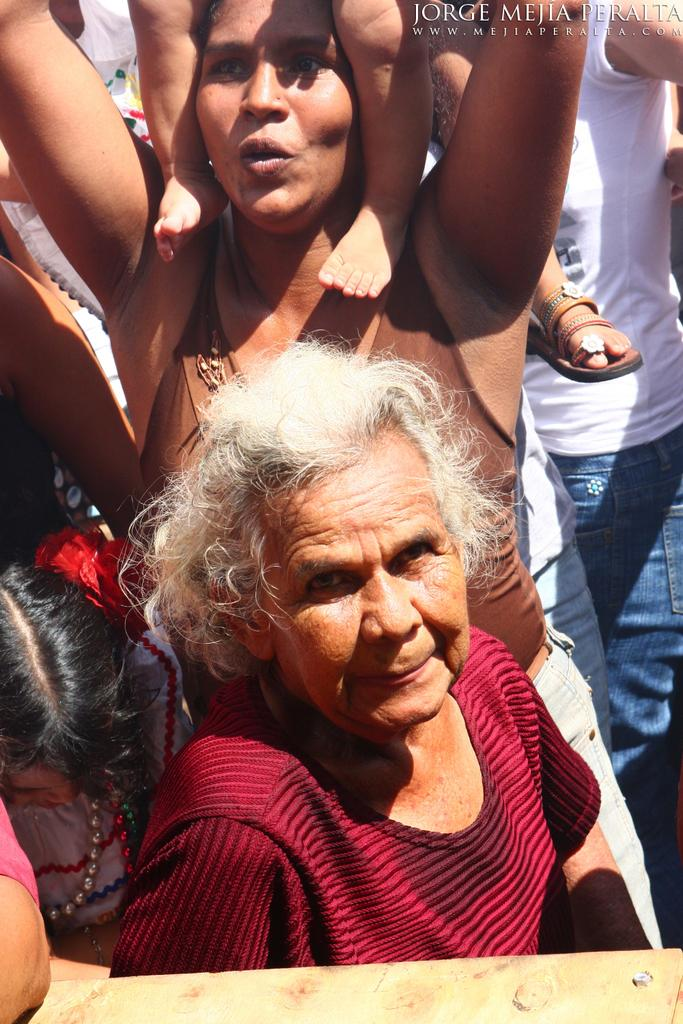Who is the main subject in the image? There is a woman in the image. What is the woman wearing? The woman is wearing a red and maroon colored dress. What is the woman doing in the image? The woman is standing. Are there any other people in the image? Yes, there are other persons standing in the background of the image. What type of can is visible in the image? There is no can present in the image. What time of day is depicted in the image? The provided facts do not mention the time of day, so it cannot be determined from the image. 